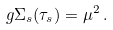Convert formula to latex. <formula><loc_0><loc_0><loc_500><loc_500>g \Sigma _ { s } ( \tau _ { s } ) = \mu ^ { 2 } \, .</formula> 